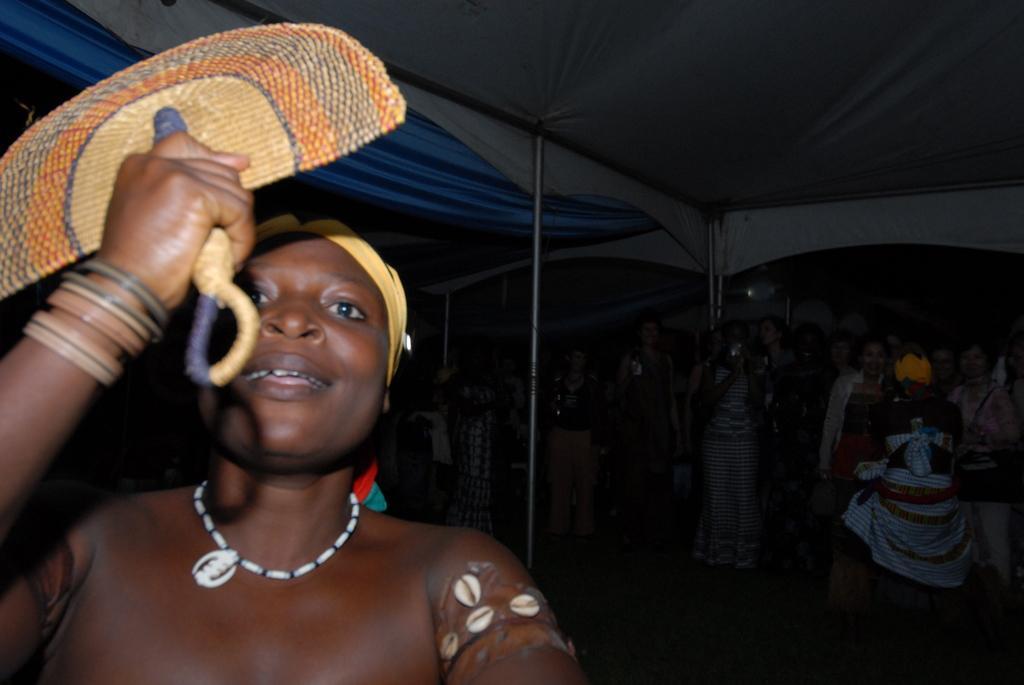Can you describe this image briefly? In this picture we can see a person holding a hand fan and smiling and in the background we can see a group of people standing, poles, tents and some objects. 